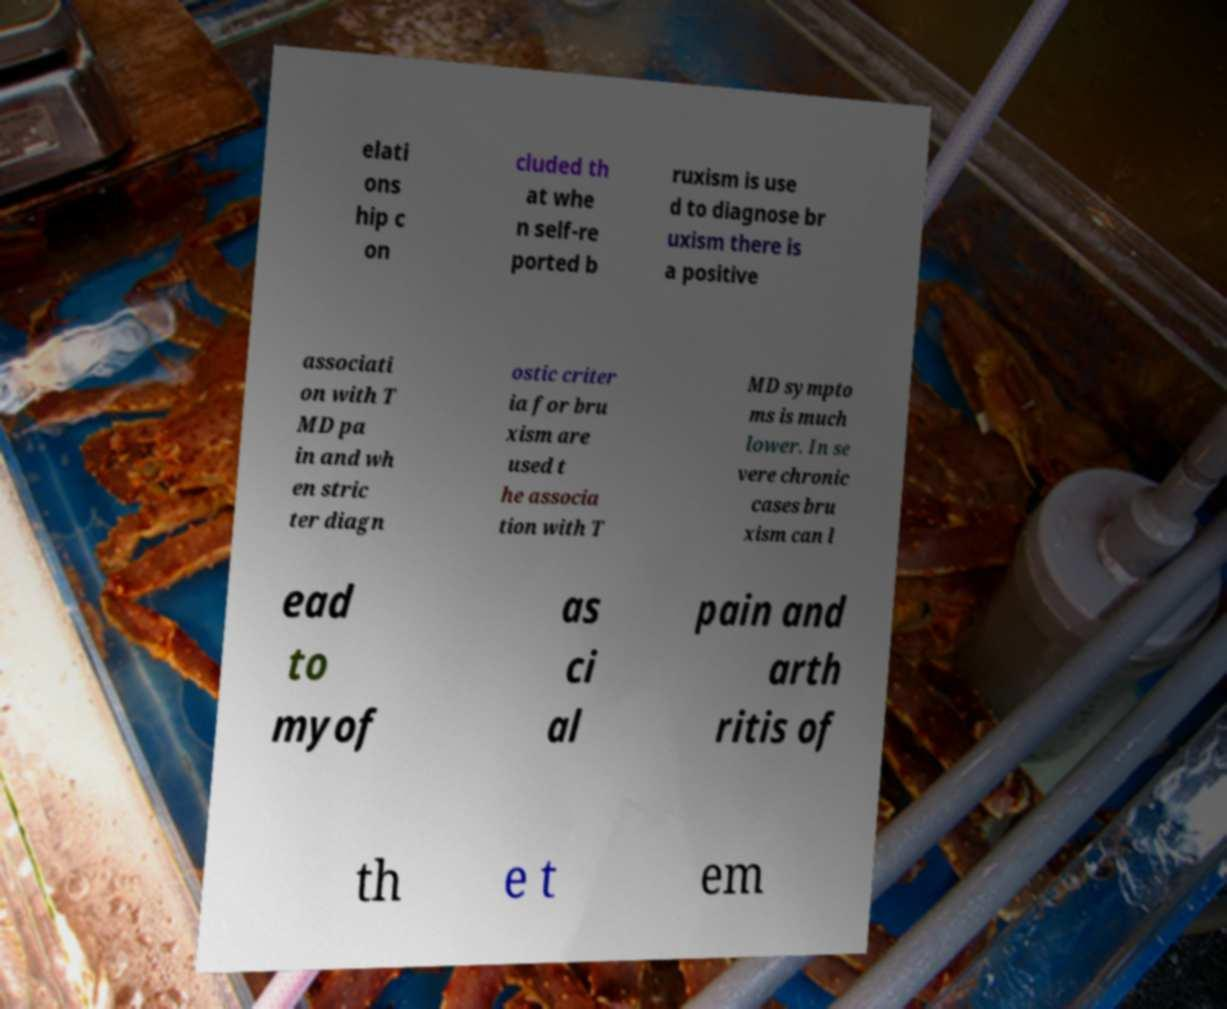There's text embedded in this image that I need extracted. Can you transcribe it verbatim? elati ons hip c on cluded th at whe n self-re ported b ruxism is use d to diagnose br uxism there is a positive associati on with T MD pa in and wh en stric ter diagn ostic criter ia for bru xism are used t he associa tion with T MD sympto ms is much lower. In se vere chronic cases bru xism can l ead to myof as ci al pain and arth ritis of th e t em 